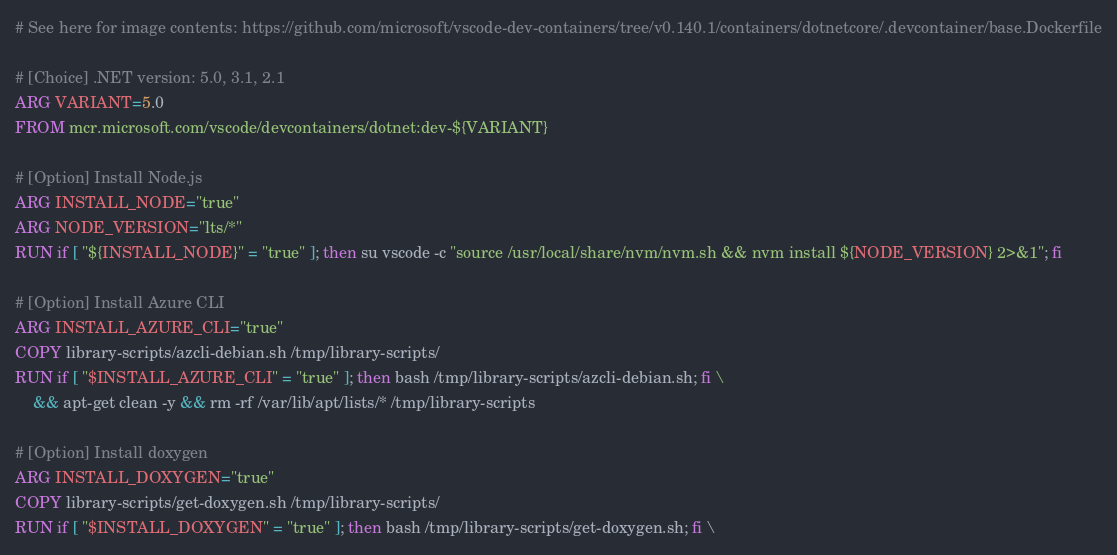Convert code to text. <code><loc_0><loc_0><loc_500><loc_500><_Dockerfile_># See here for image contents: https://github.com/microsoft/vscode-dev-containers/tree/v0.140.1/containers/dotnetcore/.devcontainer/base.Dockerfile

# [Choice] .NET version: 5.0, 3.1, 2.1
ARG VARIANT=5.0
FROM mcr.microsoft.com/vscode/devcontainers/dotnet:dev-${VARIANT}

# [Option] Install Node.js
ARG INSTALL_NODE="true"
ARG NODE_VERSION="lts/*"
RUN if [ "${INSTALL_NODE}" = "true" ]; then su vscode -c "source /usr/local/share/nvm/nvm.sh && nvm install ${NODE_VERSION} 2>&1"; fi

# [Option] Install Azure CLI
ARG INSTALL_AZURE_CLI="true"
COPY library-scripts/azcli-debian.sh /tmp/library-scripts/
RUN if [ "$INSTALL_AZURE_CLI" = "true" ]; then bash /tmp/library-scripts/azcli-debian.sh; fi \
    && apt-get clean -y && rm -rf /var/lib/apt/lists/* /tmp/library-scripts

# [Option] Install doxygen
ARG INSTALL_DOXYGEN="true"
COPY library-scripts/get-doxygen.sh /tmp/library-scripts/
RUN if [ "$INSTALL_DOXYGEN" = "true" ]; then bash /tmp/library-scripts/get-doxygen.sh; fi \</code> 